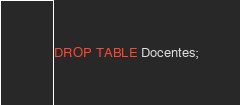<code> <loc_0><loc_0><loc_500><loc_500><_SQL_>DROP TABLE Docentes;</code> 